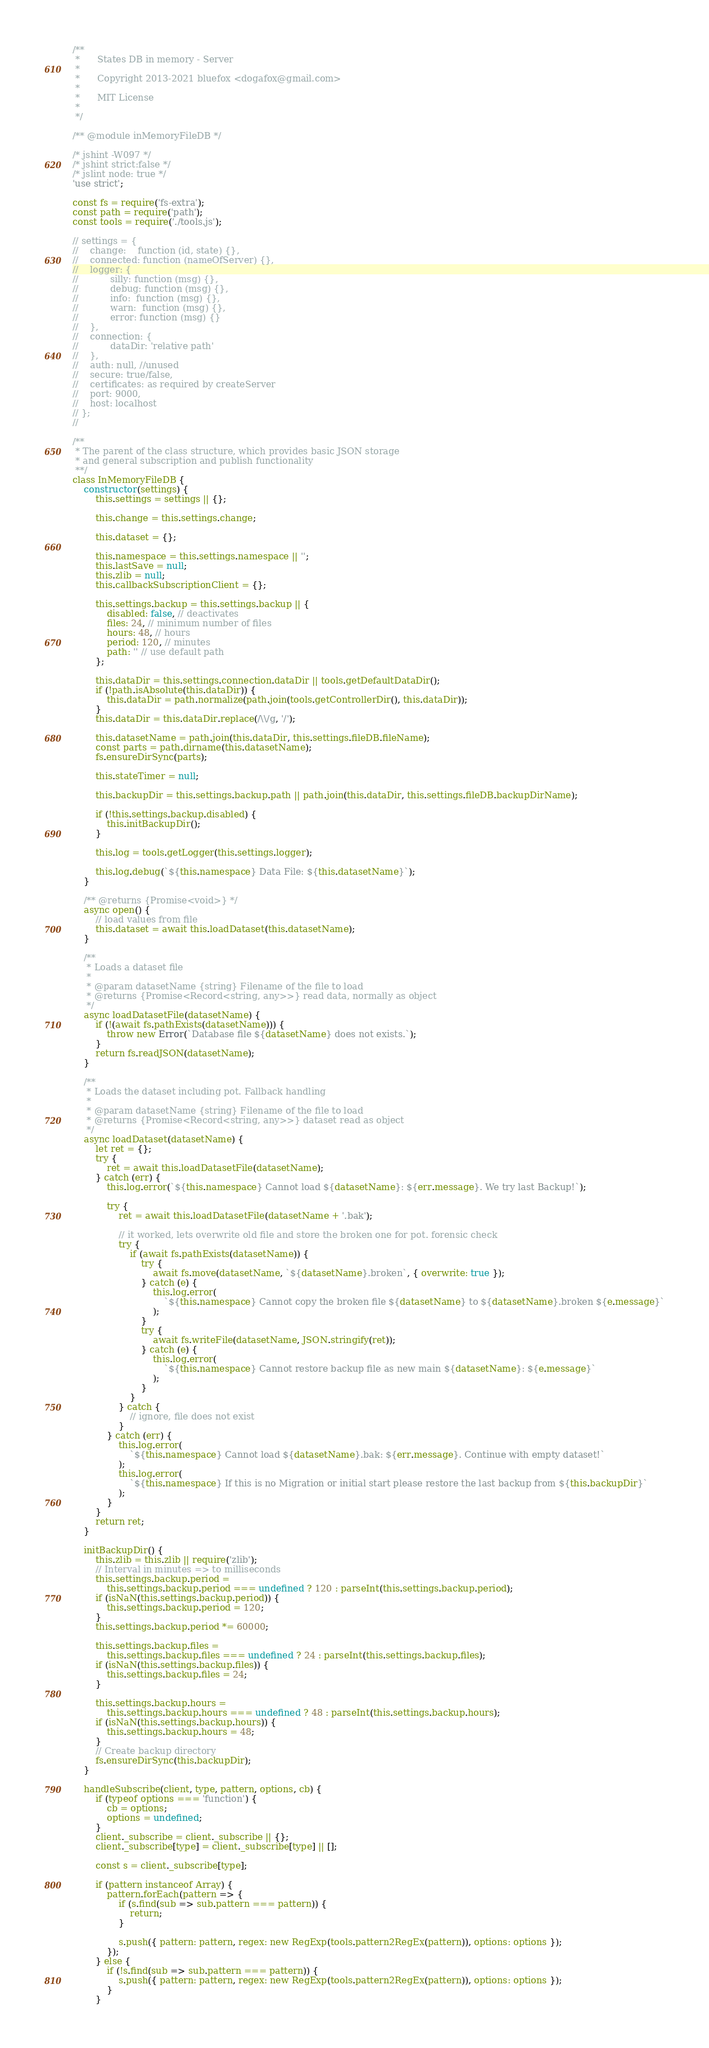Convert code to text. <code><loc_0><loc_0><loc_500><loc_500><_JavaScript_>/**
 *      States DB in memory - Server
 *
 *      Copyright 2013-2021 bluefox <dogafox@gmail.com>
 *
 *      MIT License
 *
 */

/** @module inMemoryFileDB */

/* jshint -W097 */
/* jshint strict:false */
/* jslint node: true */
'use strict';

const fs = require('fs-extra');
const path = require('path');
const tools = require('./tools.js');

// settings = {
//    change:    function (id, state) {},
//    connected: function (nameOfServer) {},
//    logger: {
//           silly: function (msg) {},
//           debug: function (msg) {},
//           info:  function (msg) {},
//           warn:  function (msg) {},
//           error: function (msg) {}
//    },
//    connection: {
//           dataDir: 'relative path'
//    },
//    auth: null, //unused
//    secure: true/false,
//    certificates: as required by createServer
//    port: 9000,
//    host: localhost
// };
//

/**
 * The parent of the class structure, which provides basic JSON storage
 * and general subscription and publish functionality
 **/
class InMemoryFileDB {
    constructor(settings) {
        this.settings = settings || {};

        this.change = this.settings.change;

        this.dataset = {};

        this.namespace = this.settings.namespace || '';
        this.lastSave = null;
        this.zlib = null;
        this.callbackSubscriptionClient = {};

        this.settings.backup = this.settings.backup || {
            disabled: false, // deactivates
            files: 24, // minimum number of files
            hours: 48, // hours
            period: 120, // minutes
            path: '' // use default path
        };

        this.dataDir = this.settings.connection.dataDir || tools.getDefaultDataDir();
        if (!path.isAbsolute(this.dataDir)) {
            this.dataDir = path.normalize(path.join(tools.getControllerDir(), this.dataDir));
        }
        this.dataDir = this.dataDir.replace(/\\/g, '/');

        this.datasetName = path.join(this.dataDir, this.settings.fileDB.fileName);
        const parts = path.dirname(this.datasetName);
        fs.ensureDirSync(parts);

        this.stateTimer = null;

        this.backupDir = this.settings.backup.path || path.join(this.dataDir, this.settings.fileDB.backupDirName);

        if (!this.settings.backup.disabled) {
            this.initBackupDir();
        }

        this.log = tools.getLogger(this.settings.logger);

        this.log.debug(`${this.namespace} Data File: ${this.datasetName}`);
    }

    /** @returns {Promise<void>} */
    async open() {
        // load values from file
        this.dataset = await this.loadDataset(this.datasetName);
    }

    /**
     * Loads a dataset file
     *
     * @param datasetName {string} Filename of the file to load
     * @returns {Promise<Record<string, any>>} read data, normally as object
     */
    async loadDatasetFile(datasetName) {
        if (!(await fs.pathExists(datasetName))) {
            throw new Error(`Database file ${datasetName} does not exists.`);
        }
        return fs.readJSON(datasetName);
    }

    /**
     * Loads the dataset including pot. Fallback handling
     *
     * @param datasetName {string} Filename of the file to load
     * @returns {Promise<Record<string, any>>} dataset read as object
     */
    async loadDataset(datasetName) {
        let ret = {};
        try {
            ret = await this.loadDatasetFile(datasetName);
        } catch (err) {
            this.log.error(`${this.namespace} Cannot load ${datasetName}: ${err.message}. We try last Backup!`);

            try {
                ret = await this.loadDatasetFile(datasetName + '.bak');

                // it worked, lets overwrite old file and store the broken one for pot. forensic check
                try {
                    if (await fs.pathExists(datasetName)) {
                        try {
                            await fs.move(datasetName, `${datasetName}.broken`, { overwrite: true });
                        } catch (e) {
                            this.log.error(
                                `${this.namespace} Cannot copy the broken file ${datasetName} to ${datasetName}.broken ${e.message}`
                            );
                        }
                        try {
                            await fs.writeFile(datasetName, JSON.stringify(ret));
                        } catch (e) {
                            this.log.error(
                                `${this.namespace} Cannot restore backup file as new main ${datasetName}: ${e.message}`
                            );
                        }
                    }
                } catch {
                    // ignore, file does not exist
                }
            } catch (err) {
                this.log.error(
                    `${this.namespace} Cannot load ${datasetName}.bak: ${err.message}. Continue with empty dataset!`
                );
                this.log.error(
                    `${this.namespace} If this is no Migration or initial start please restore the last backup from ${this.backupDir}`
                );
            }
        }
        return ret;
    }

    initBackupDir() {
        this.zlib = this.zlib || require('zlib');
        // Interval in minutes => to milliseconds
        this.settings.backup.period =
            this.settings.backup.period === undefined ? 120 : parseInt(this.settings.backup.period);
        if (isNaN(this.settings.backup.period)) {
            this.settings.backup.period = 120;
        }
        this.settings.backup.period *= 60000;

        this.settings.backup.files =
            this.settings.backup.files === undefined ? 24 : parseInt(this.settings.backup.files);
        if (isNaN(this.settings.backup.files)) {
            this.settings.backup.files = 24;
        }

        this.settings.backup.hours =
            this.settings.backup.hours === undefined ? 48 : parseInt(this.settings.backup.hours);
        if (isNaN(this.settings.backup.hours)) {
            this.settings.backup.hours = 48;
        }
        // Create backup directory
        fs.ensureDirSync(this.backupDir);
    }

    handleSubscribe(client, type, pattern, options, cb) {
        if (typeof options === 'function') {
            cb = options;
            options = undefined;
        }
        client._subscribe = client._subscribe || {};
        client._subscribe[type] = client._subscribe[type] || [];

        const s = client._subscribe[type];

        if (pattern instanceof Array) {
            pattern.forEach(pattern => {
                if (s.find(sub => sub.pattern === pattern)) {
                    return;
                }

                s.push({ pattern: pattern, regex: new RegExp(tools.pattern2RegEx(pattern)), options: options });
            });
        } else {
            if (!s.find(sub => sub.pattern === pattern)) {
                s.push({ pattern: pattern, regex: new RegExp(tools.pattern2RegEx(pattern)), options: options });
            }
        }</code> 